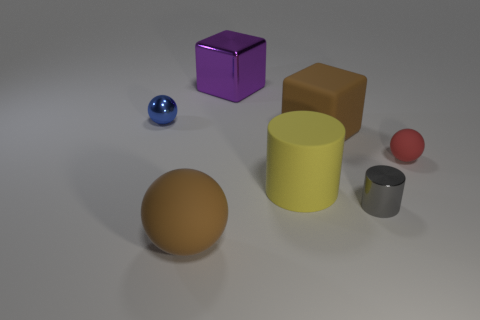Subtract all blue shiny spheres. How many spheres are left? 2 Add 2 blue metallic blocks. How many objects exist? 9 Subtract all cyan balls. Subtract all green blocks. How many balls are left? 3 Subtract all cubes. How many objects are left? 5 Subtract 0 blue cylinders. How many objects are left? 7 Subtract all yellow objects. Subtract all yellow blocks. How many objects are left? 6 Add 1 small gray shiny cylinders. How many small gray shiny cylinders are left? 2 Add 2 large purple blocks. How many large purple blocks exist? 3 